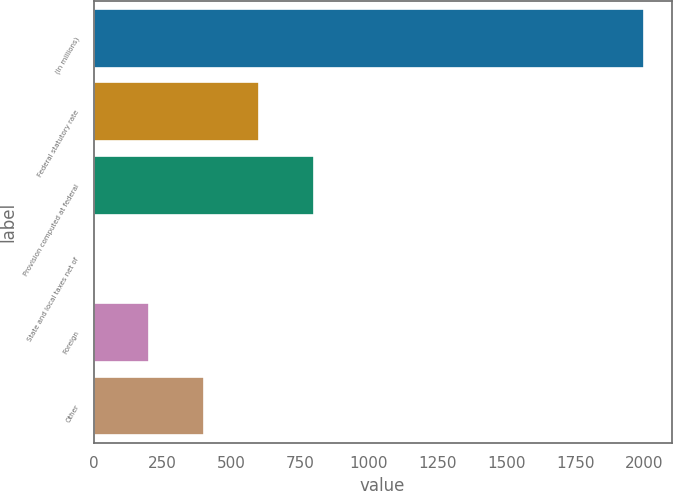Convert chart to OTSL. <chart><loc_0><loc_0><loc_500><loc_500><bar_chart><fcel>(In millions)<fcel>Federal statutory rate<fcel>Provision computed at federal<fcel>State and local taxes net of<fcel>Foreign<fcel>Other<nl><fcel>2000<fcel>602.31<fcel>801.98<fcel>3.3<fcel>202.97<fcel>402.64<nl></chart> 